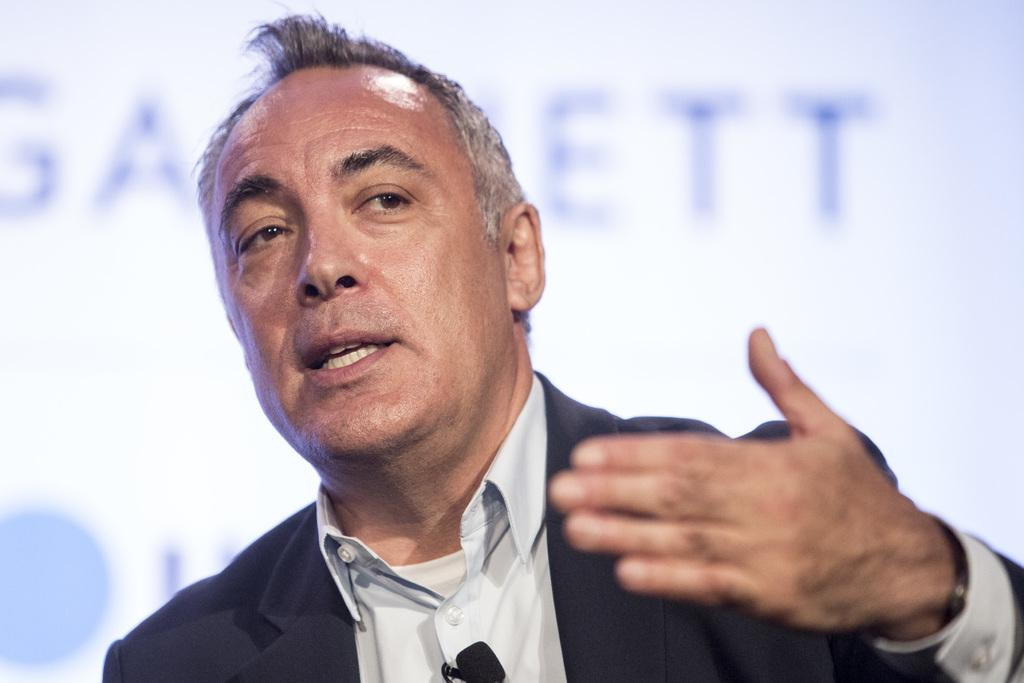Who is present in the image? There is a man in the image. What is the man doing in the image? The man is talking. Can you describe the background of the image? The background of the image is blurry. What type of goat can be seen in the image? There is no goat present in the image. How much salt is visible in the image? There is no salt present in the image. 